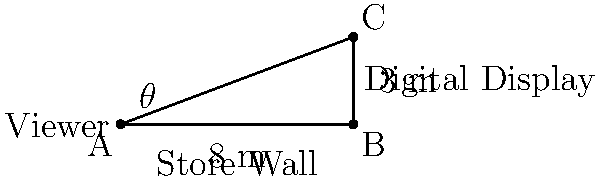You're installing a digital display in a store. The display is mounted 3 meters above eye level and 8 meters away from the viewing position. What is the optimal viewing angle $\theta$ (in degrees) for customers looking at the display? To find the optimal viewing angle, we need to use the arctangent function. Here's how we can solve this step-by-step:

1. Identify the right triangle formed by the viewer's eye level, the display, and the imaginary line connecting them.

2. The adjacent side of the triangle is the horizontal distance from the viewer to the wall (8 meters).

3. The opposite side is the height of the display above eye level (3 meters).

4. The angle $\theta$ is formed between the adjacent side and the hypotenuse.

5. We can use the arctangent function to find this angle:

   $\theta = \arctan(\frac{\text{opposite}}{\text{adjacent}})$

6. Plugging in our values:

   $\theta = \arctan(\frac{3}{8})$

7. Using a calculator or programming function to evaluate this:

   $\theta \approx 20.556$ degrees

8. Rounding to the nearest degree:

   $\theta \approx 21$ degrees

This angle provides the optimal viewing experience for customers looking at the digital display.
Answer: $21°$ 